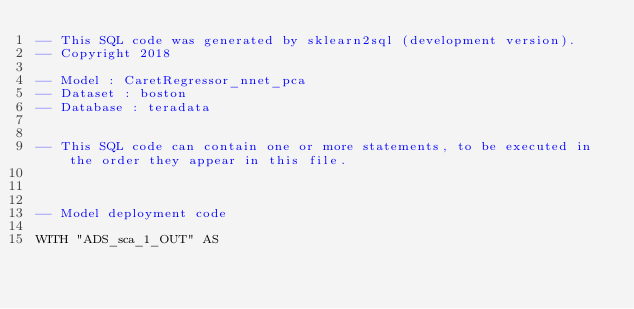<code> <loc_0><loc_0><loc_500><loc_500><_SQL_>-- This SQL code was generated by sklearn2sql (development version).
-- Copyright 2018

-- Model : CaretRegressor_nnet_pca
-- Dataset : boston
-- Database : teradata


-- This SQL code can contain one or more statements, to be executed in the order they appear in this file.



-- Model deployment code

WITH "ADS_sca_1_OUT" AS </code> 